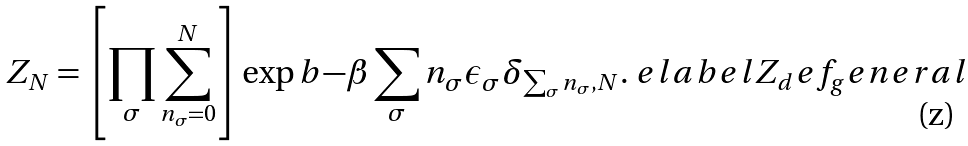Convert formula to latex. <formula><loc_0><loc_0><loc_500><loc_500>Z _ { N } = \left [ \prod _ { \sigma } \sum _ { n _ { \sigma } = 0 } ^ { N } \right ] \exp b { - \beta \sum _ { \sigma } n _ { \sigma } \epsilon _ { \sigma } } \delta _ { \sum _ { \sigma } n _ { \sigma } , N } . \ e l a b e l { Z _ { d } e f _ { g } e n e r a l }</formula> 